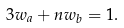<formula> <loc_0><loc_0><loc_500><loc_500>3 w _ { a } + n w _ { b } = 1 .</formula> 